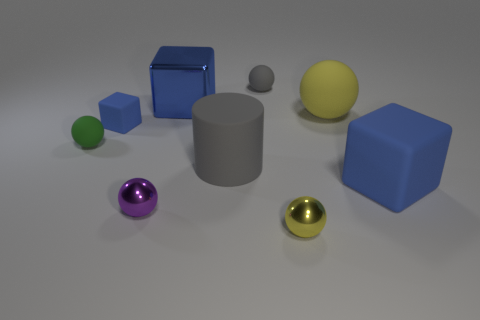There is a large block that is left of the gray rubber object in front of the yellow ball that is behind the large blue rubber block; what is its material?
Your answer should be very brief. Metal. There is a shiny object that is on the right side of the big blue metallic thing; how many big objects are to the right of it?
Give a very brief answer. 2. There is a tiny rubber thing that is the same shape as the large blue metallic object; what is its color?
Offer a very short reply. Blue. Is the material of the large yellow sphere the same as the small gray sphere?
Offer a terse response. Yes. How many blocks are either yellow metal objects or tiny shiny things?
Keep it short and to the point. 0. There is a gray thing behind the big cube behind the large rubber thing behind the tiny block; what size is it?
Provide a short and direct response. Small. What is the size of the purple metallic thing that is the same shape as the small yellow thing?
Ensure brevity in your answer.  Small. There is a large yellow rubber thing; how many cubes are to the left of it?
Make the answer very short. 2. There is a metallic object behind the purple metal thing; does it have the same color as the cylinder?
Your answer should be very brief. No. What number of purple objects are either matte things or rubber cubes?
Your answer should be very brief. 0. 